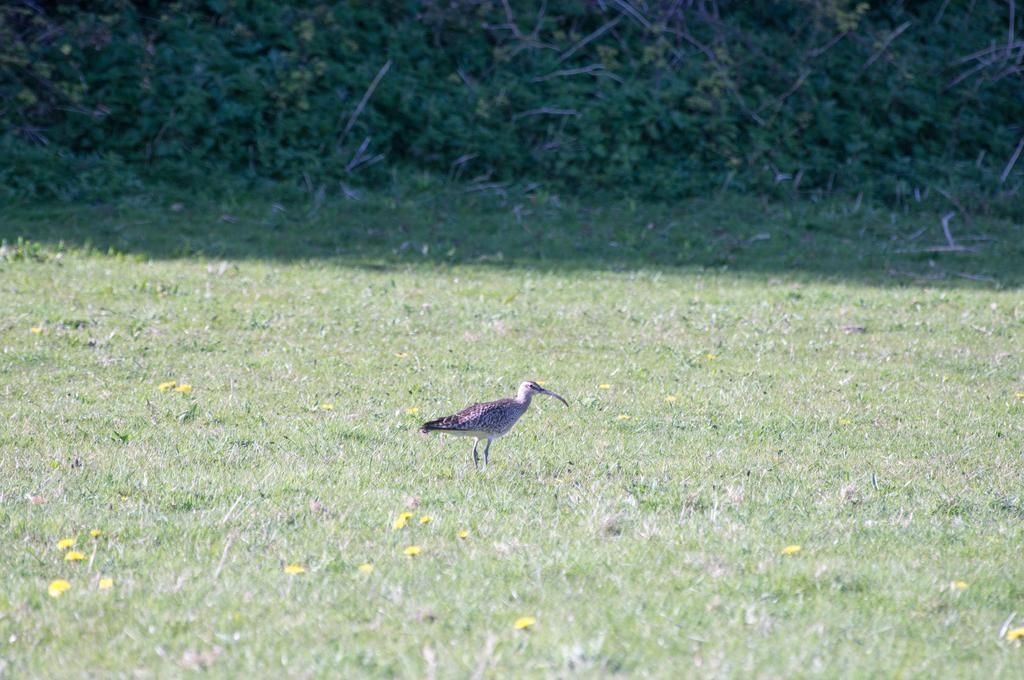What is the main subject in the middle of the image? There is a bird in the middle of the image. What type of terrain is visible in the image? There is grass on the ground in the image. Are there any additional features among the grass? Yes, there are yellow flowers among the grass. What can be seen in the background of the image? There are plants in the background of the image. What type of jewel can be seen in the image? There is no jewel present in the image; it features a bird, grass, yellow flowers, and plants. How does the pollution affect the bird in the image? There is no indication of pollution in the image, so it cannot be determined how it might affect the bird. 